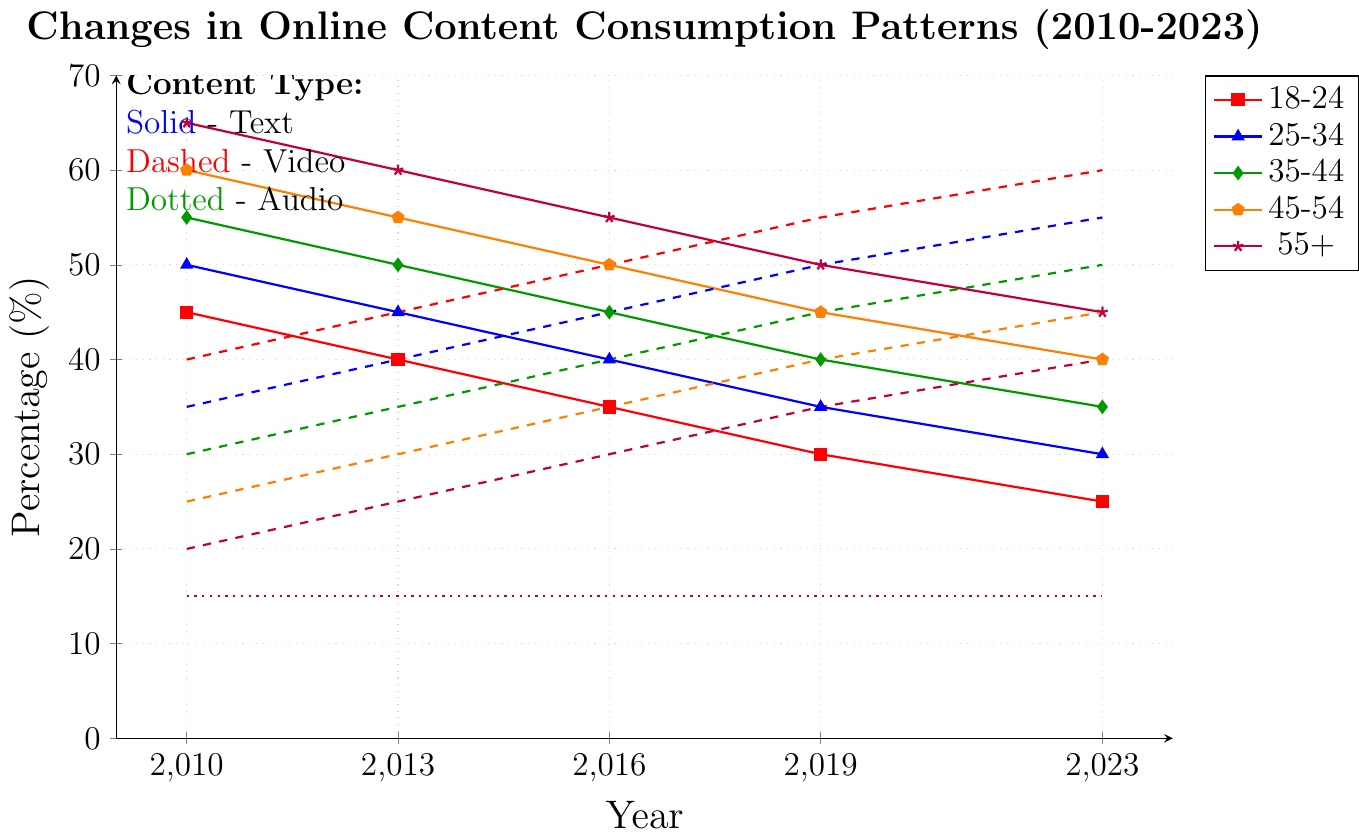What's the trend in video content consumption for the age group 18-24 from 2010 to 2023? The red dashed line represents video content for the age group 18-24. The consumption percentage increased from 40% in 2010 to 60% in 2023.
Answer: Increase Which age group had the highest percentage of text content consumption in 2013? The blue solid lines indicate text content consumption. In 2013, the age group 55+ had the highest percentage at 60%.
Answer: 55+ Is there any age group where audio content consumption changed over the years? The green dotted lines denote audio content consumption. They are all flat at 15% across different years for all age groups, showing no change in audio consumption over the years.
Answer: No By how much did text content consumption decrease for the age group 45-54 from 2010 to 2023? Refer to the blue solid line for age group 45-54. In 2010, the percentage was 60%, and in 2023, it was 40%, a decrease of 20%.
Answer: 20% Compare the video content consumption percentages between the age groups 25-34 and 35-44 in 2016. Which one is higher? Refer to the red dashed lines for 2016. The percentage for 25-34 is 45% and for 35-44 is 40%. Thus, 25-34 has a higher consumption.
Answer: 25-34 Calculate the average video content consumption for the age group 18-24 over the years 2010, 2013, 2016, 2019, and 2023. Sum up the video consumption percentages for 18-24 (40, 45, 50, 55, 60) and divide by 5. (40 + 45 + 50 + 55 + 60) / 5 = 50%
Answer: 50% Which age group showed the least decline in text content consumption from 2010 to 2023? Examine all the blue solid lines. The age group 18-24 declined from 45% to 25%, showing a decrease of 20%, which is the least among all age groups.
Answer: 18-24 Compare the change in video content consumption between the age groups 45-54 and 55+ from 2010 to 2023. Which group had a greater increase? For age group 45-54, video consumption increased from 25% to 45%, a 20% increase. For age group 55+, it increased from 20% to 40%, also a 20% increase. Both groups had the same increase.
Answer: Same What is the percentage difference between text and video content consumption for the age group 35-44 in 2023? In 2023, for age group 35-44, text content is 35% and video content is 50%. The difference is 50% - 35% = 15%.
Answer: 15% Identify the age group that has the most equal distribution in content types in 2023. In 2023, for each age group, the percentages for text, video, and audio are as follows: 
- 18-24: Text 25%, Video 60%, Audio 15%
- 25-34: Text 30%, Video 55%, Audio 15%
- 35-44: Text 35%, Video 50%, Audio 15%
- 45-54: Text 40%, Video 45%, Audio 15%
- 55+: Text 45%, Video 40%, Audio 15%
   
The age group 45-54 has the most balanced values, with the closest percentages across the three types.
Answer: 45-54 